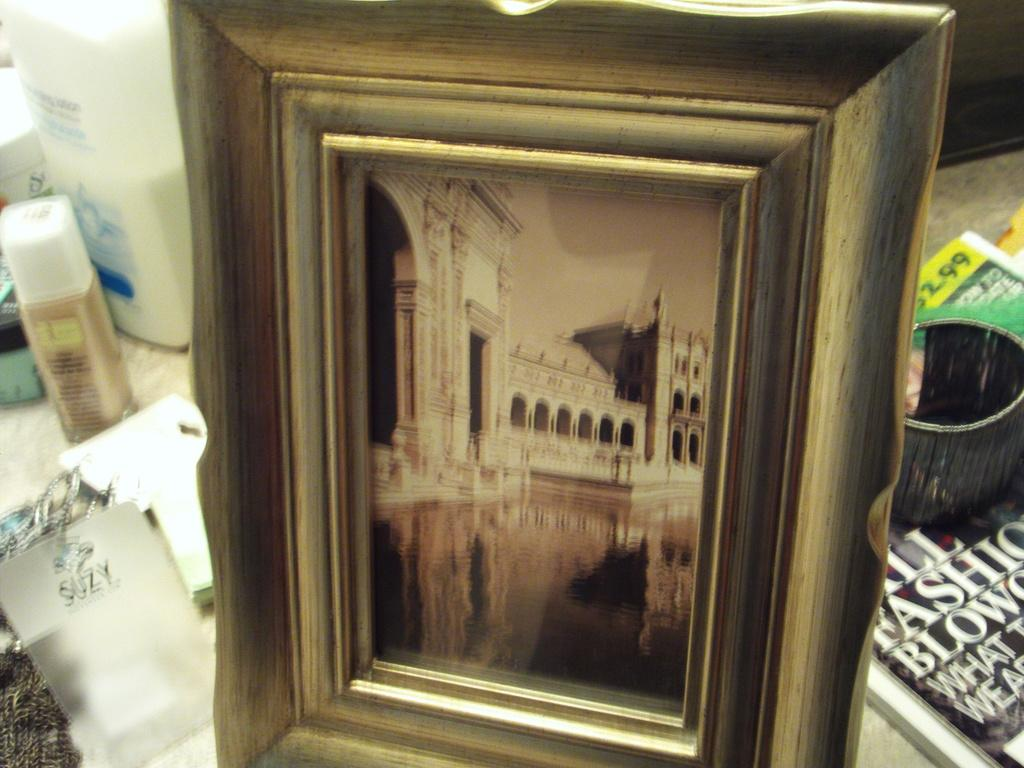What is the main subject of the image? The main subject of the image is a frame. What can be seen inside the frame? Inside the frame, there is a building and water. What is present on the surface in the image? There are books and other objects on the surface in the image. What direction is the ink flowing in the image? There is no ink present in the image, so it cannot be determined in which direction it might be flowing. 